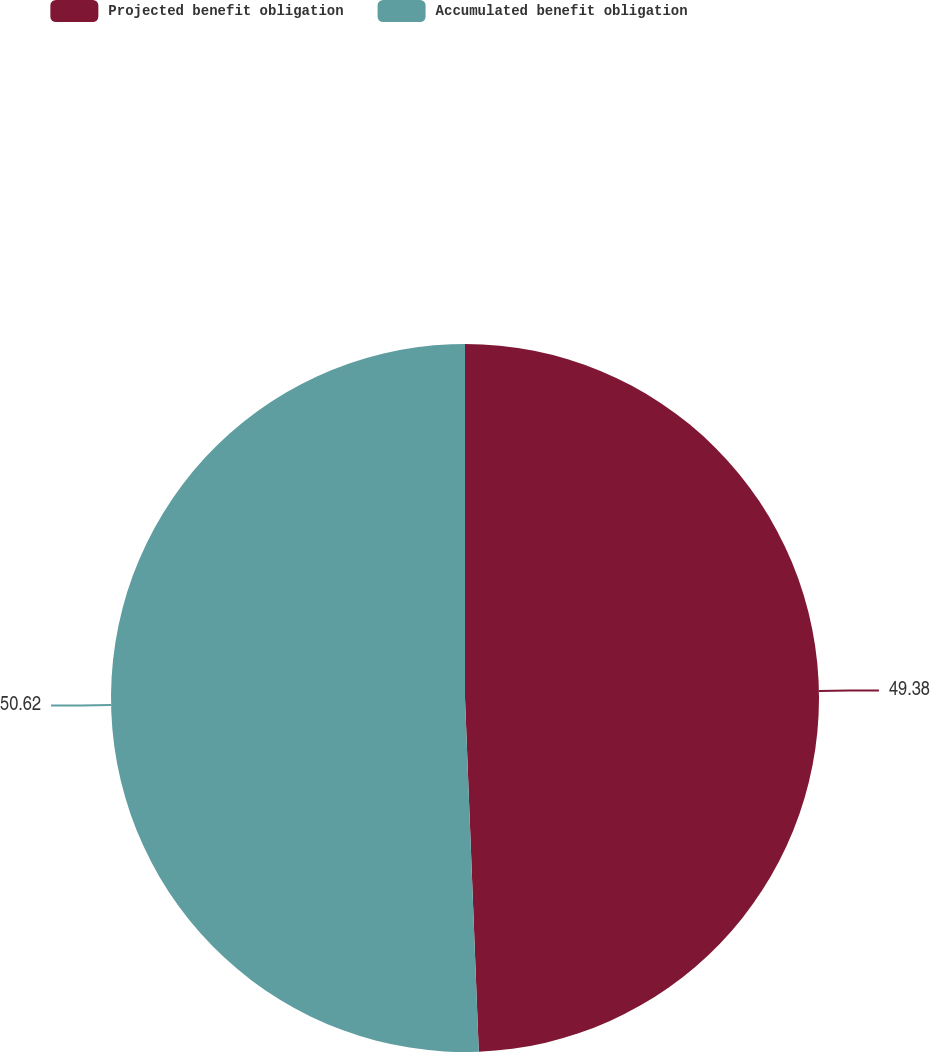<chart> <loc_0><loc_0><loc_500><loc_500><pie_chart><fcel>Projected benefit obligation<fcel>Accumulated benefit obligation<nl><fcel>49.38%<fcel>50.62%<nl></chart> 